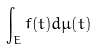Convert formula to latex. <formula><loc_0><loc_0><loc_500><loc_500>\int _ { E } f ( t ) d \mu ( t )</formula> 